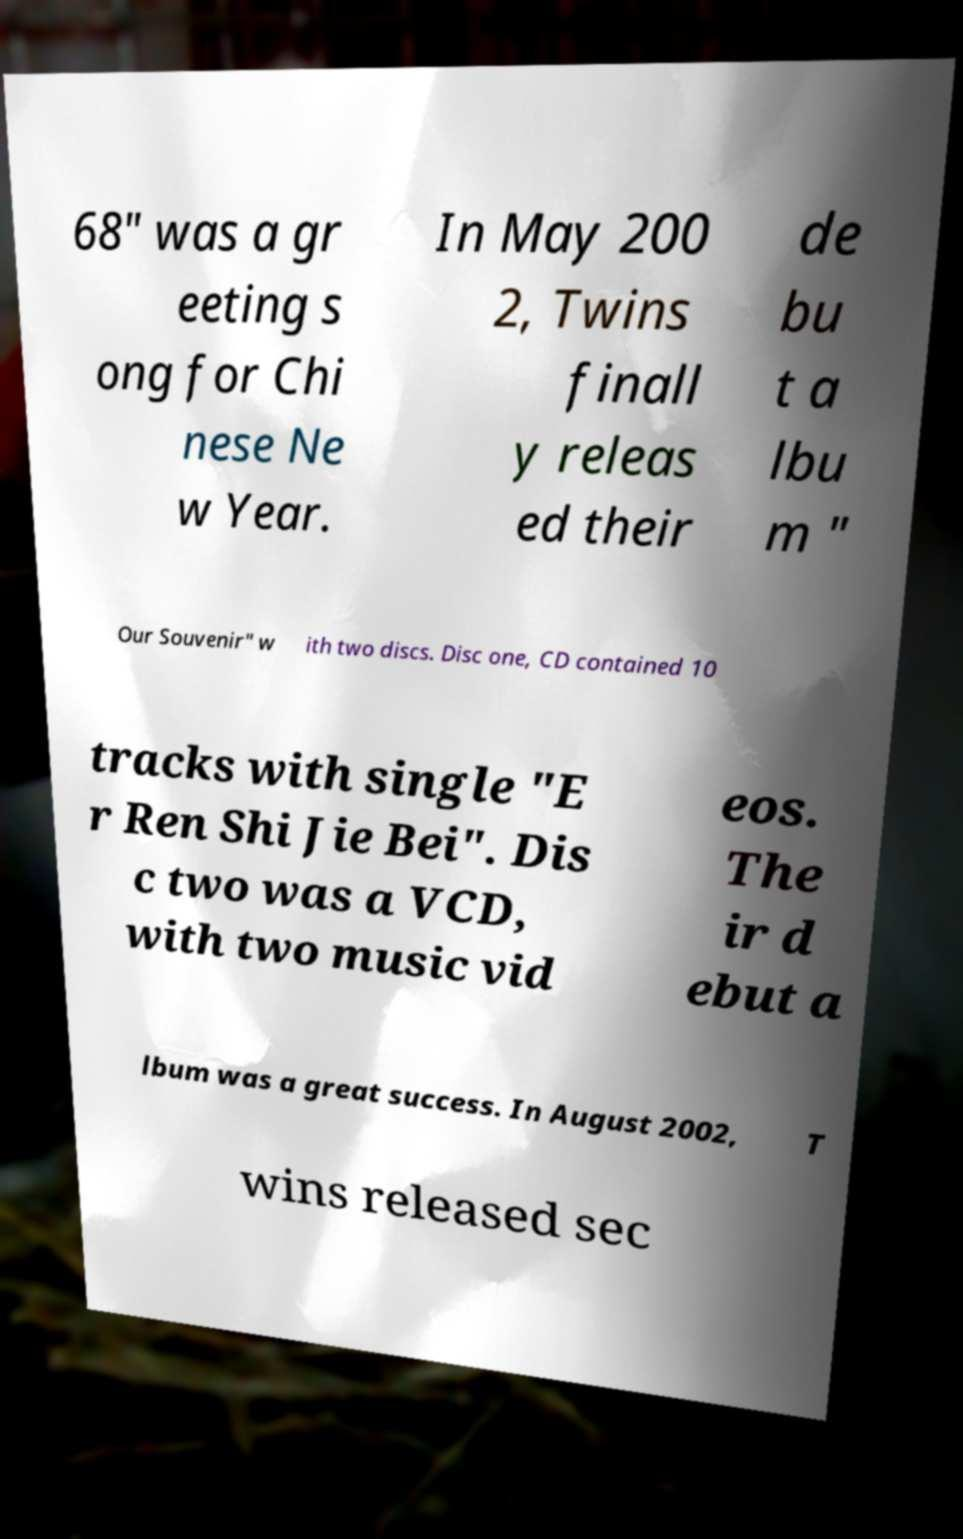Please identify and transcribe the text found in this image. 68" was a gr eeting s ong for Chi nese Ne w Year. In May 200 2, Twins finall y releas ed their de bu t a lbu m " Our Souvenir" w ith two discs. Disc one, CD contained 10 tracks with single "E r Ren Shi Jie Bei". Dis c two was a VCD, with two music vid eos. The ir d ebut a lbum was a great success. In August 2002, T wins released sec 